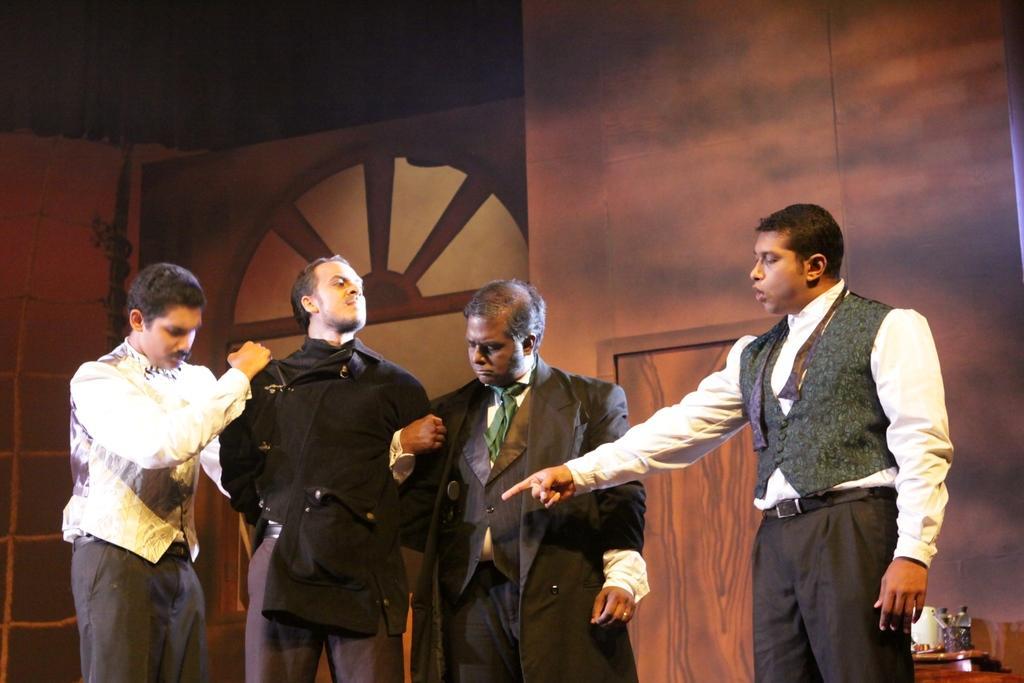Can you describe this image briefly? In this image there are objects on the right corner. There are people standing, it looks like a door in the foreground. It looks like a wooden object in the background. 